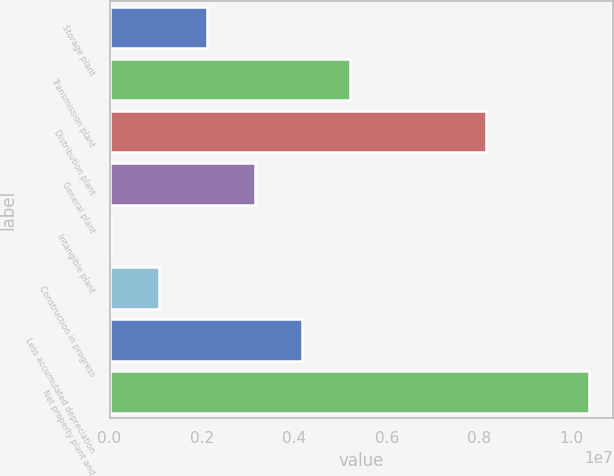Convert chart to OTSL. <chart><loc_0><loc_0><loc_500><loc_500><bar_chart><fcel>Storage plant<fcel>Transmission plant<fcel>Distribution plant<fcel>General plant<fcel>Intangible plant<fcel>Construction in progress<fcel>Less accumulated depreciation<fcel>Net property plant and<nl><fcel>2.10485e+06<fcel>5.20471e+06<fcel>8.14173e+06<fcel>3.13814e+06<fcel>38280<fcel>1.07157e+06<fcel>4.17143e+06<fcel>1.03711e+07<nl></chart> 